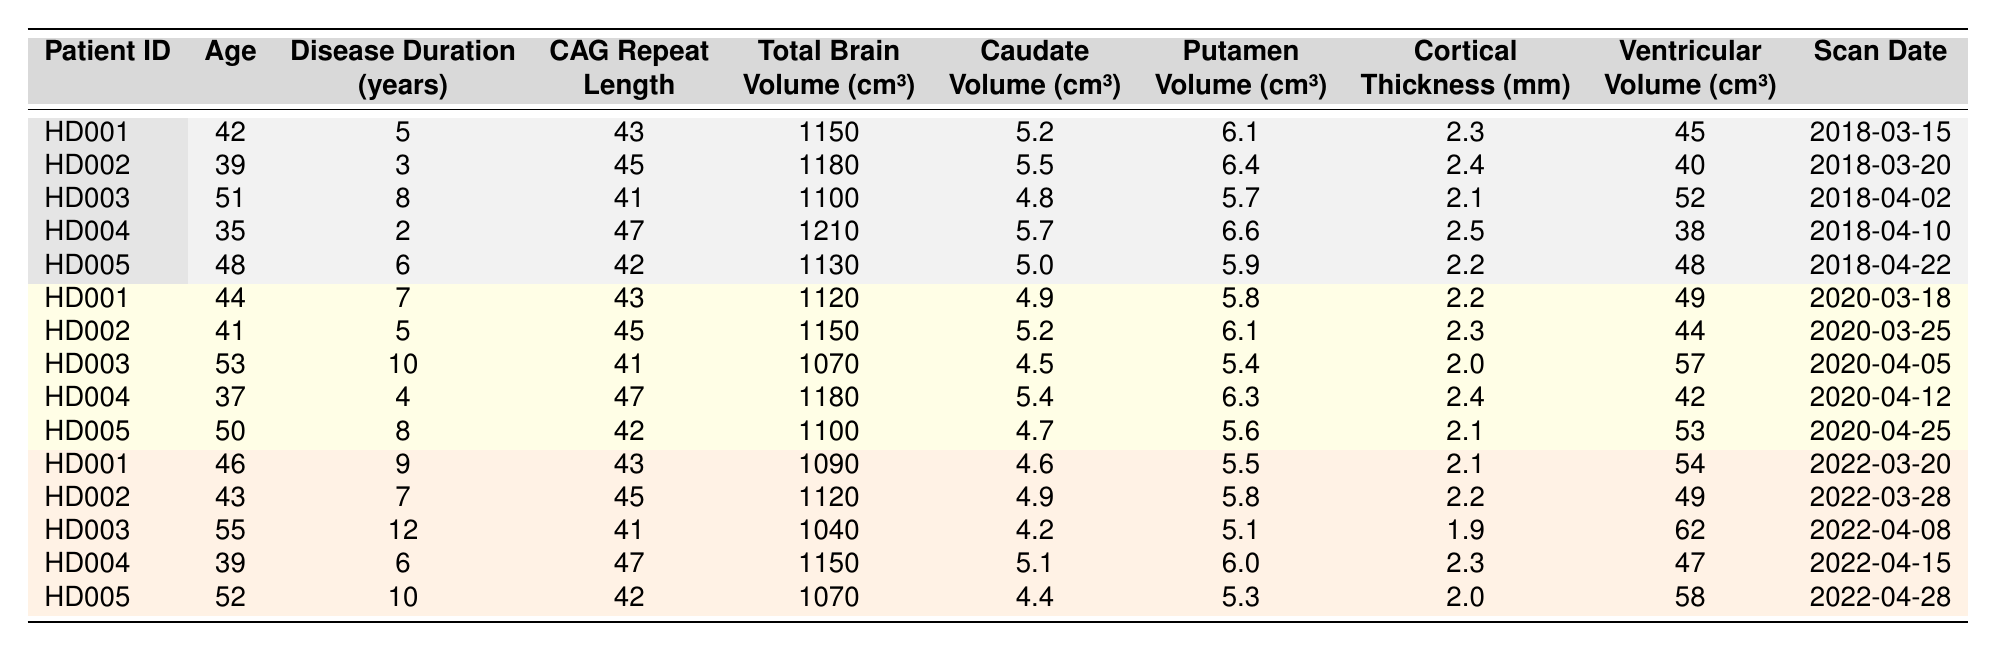What is the Total Brain Volume for Patient HD003 at the latest scan date? Looking at row for Patient HD003, the latest scan date is 2022-04-08, and the corresponding Total Brain Volume is 1040 cm³.
Answer: 1040 cm³ How many years of disease duration does Patient HD002 have at their first recorded scan? In the table, the first recorded scan date for Patient HD002 is 2018-03-20, and the Disease Duration is listed as 3 years.
Answer: 3 years What is the average Cortical Thickness across all patients at the latest scan dates? From the table, collect the Cortical Thickness values for the latest scan dates: 2.1 (HD001), 2.2 (HD002), 1.9 (HD003), 2.3 (HD004), 2.0 (HD005). Adding these gives 10.5, and dividing by 5 patients gives an average of 2.1 mm.
Answer: 2.1 mm Is the CAG Repeat Length for Patient HD005 increasing over time? Checking the data for Patient HD005, the CAG Repeat Length is consistently 42 across all recorded scans, so it does not increase over time.
Answer: No What is the difference in Total Brain Volume for Patient HD001 between the first and last scan? For Patient HD001, the Total Brain Volume is 1150 cm³ at the first scan in 2018 and 1090 cm³ at the last scan in 2022. The difference is 1150 - 1090 = 60 cm³.
Answer: 60 cm³ Which patient has the highest Ventricular Volume at the latest scan? Reviewing the latest Ventricular Volume values: HD001 has 54 cm³, HD002 has 49 cm³, HD003 has 62 cm³, HD004 has 47 cm³, and HD005 has 58 cm³. The highest is 62 cm³ for HD003.
Answer: HD003 What is the median age of patients at the latest scans? Extract ages at the latest scans: 46 (HD001), 43 (HD002), 55 (HD003), 39 (HD004), 52 (HD005). Arranging these: 39, 43, 46, 52, 55. The median is the middle value, which is 46.
Answer: 46 Do all patients have a decrease in either Caudate or Putamen Volume over time? By comparing each patient's Caudate and Putamen volumes over their scans, it can be seen that for HD001, there is a decline in Caudate (5.2 to 4.6) and Putamen (6.1 to 5.5). For other patients, while some volumes decrease, HD002 stays the same for Putamen. Therefore, not all patients show a decrease in both volumes.
Answer: No Which patient had the largest increase in Disease Duration between the first and last scan? Analyzing the Disease Durations: HD001 goes from 5 to 9 years (+4), HD002 from 3 to 7 years (+4), HD003 from 8 to 12 years (+4), HD004 from 2 to 6 years (+4), HD005 from 6 to 10 years (+4). Each patient shows an increase of 4 years.
Answer: All patients increased by 4 years 